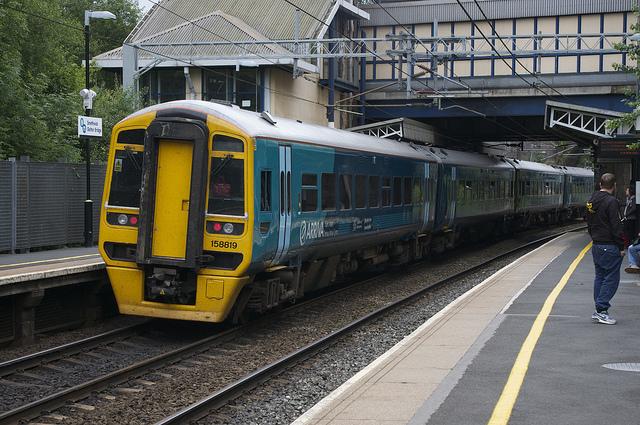Which direction is the train facing?
Quick response, please. Left. What is above the train?
Answer briefly. Building. What country is this picture taken in?
Write a very short answer. England. Are there people on the platform?
Answer briefly. Yes. Is the season winter?
Quick response, please. No. 